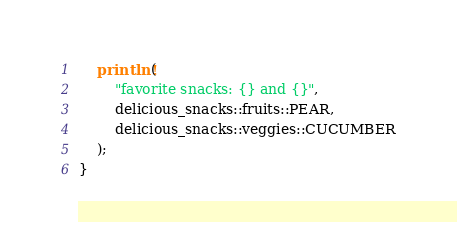Convert code to text. <code><loc_0><loc_0><loc_500><loc_500><_Rust_>    println!(
        "favorite snacks: {} and {}",
        delicious_snacks::fruits::PEAR,
        delicious_snacks::veggies::CUCUMBER
    );
}
</code> 